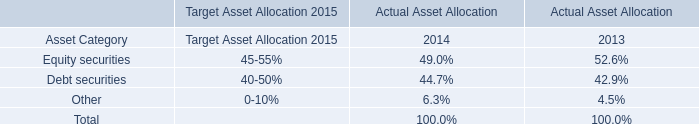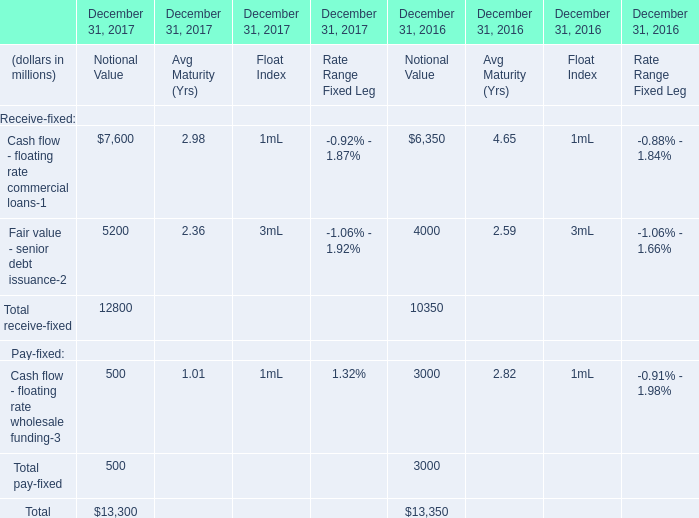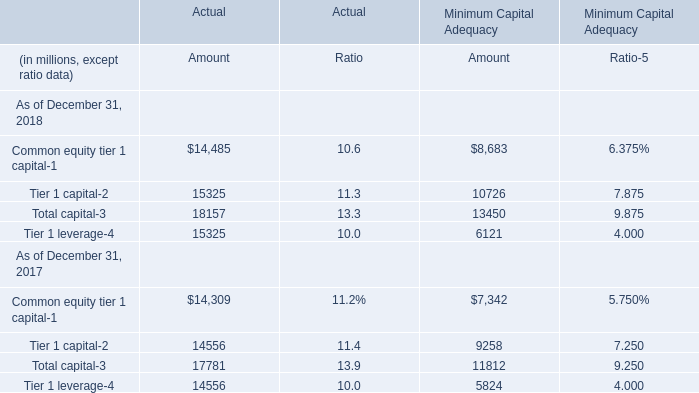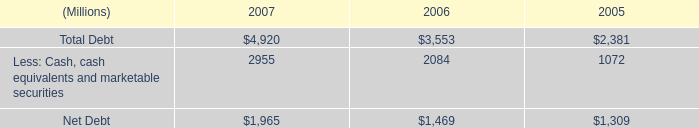What is the sum of Tier 1 capital of Actual Amount, and Net Debt of 2006 ? 
Computations: (15325.0 + 1469.0)
Answer: 16794.0. 